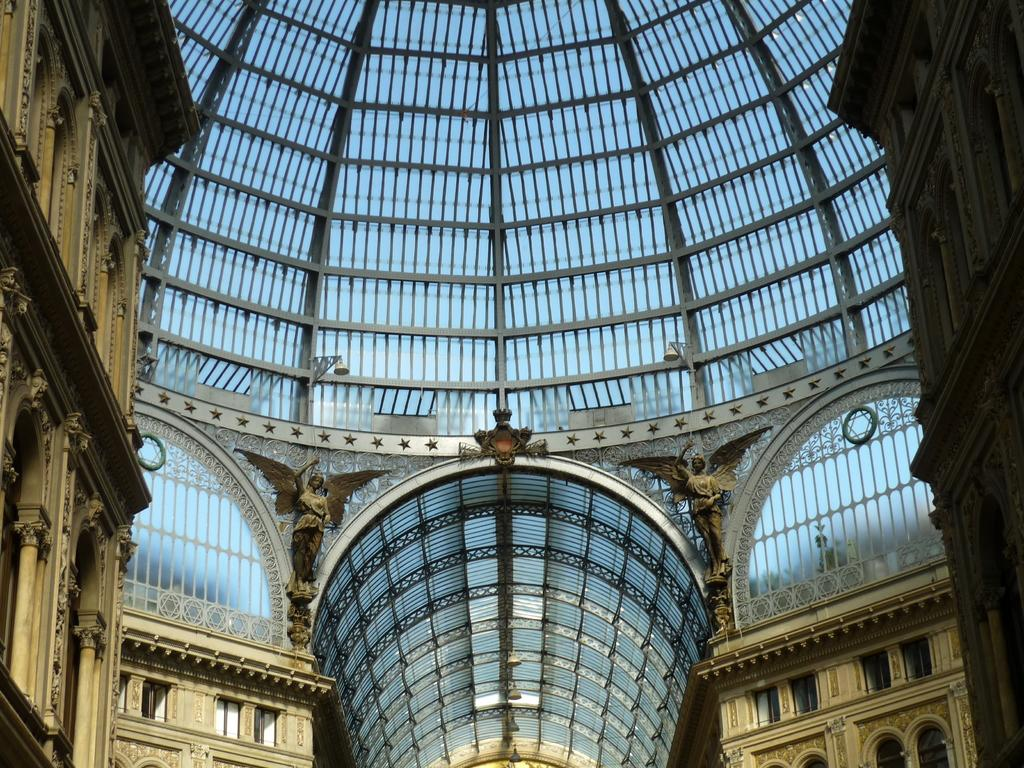What type of location is depicted in the image? The image shows an inside view of a building. What architectural features can be seen in the building? There are statues, pillars, windows, and lights visible in the building. What is visible at the top of the image? The roof is visible at the top of the image. What type of garden can be seen through the windows in the image? There is no garden visible through the windows in the image; only the roof is visible at the top. Can you tell me how many copies of the statue are present in the building? There is no information about multiple copies of the statue in the image; only one statue is visible. 